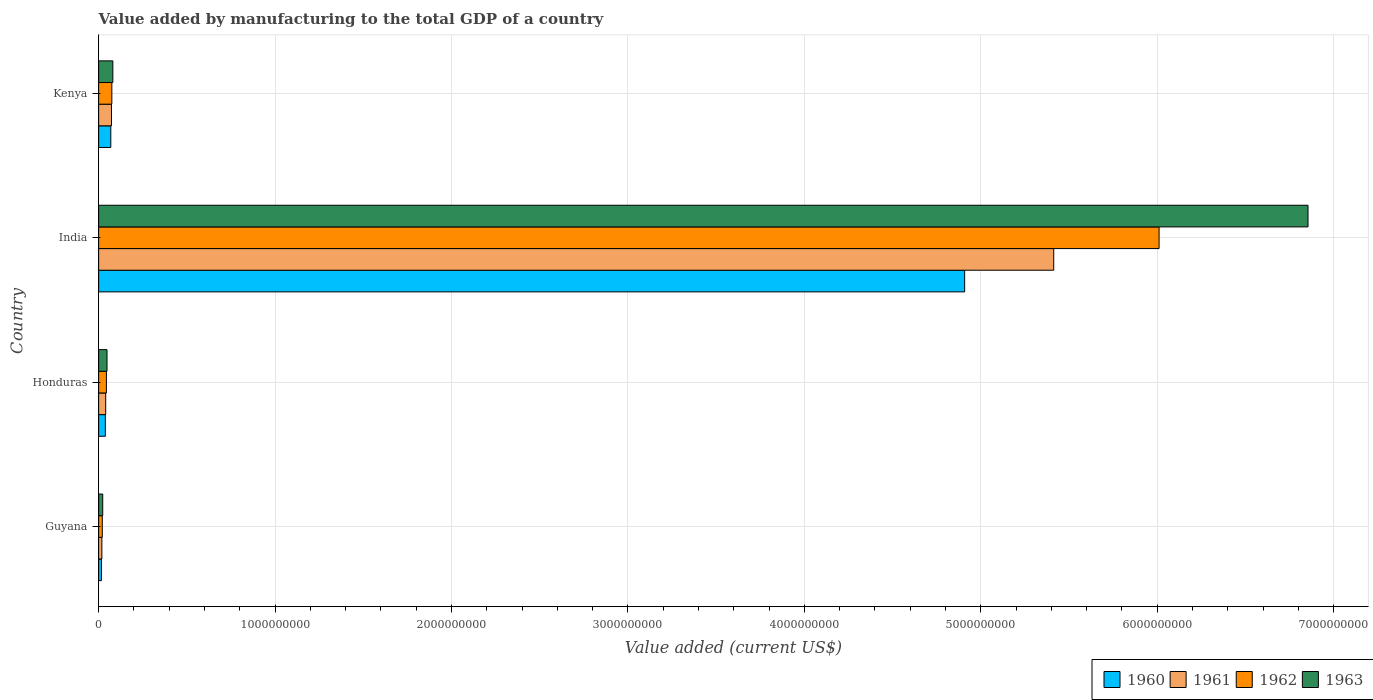How many different coloured bars are there?
Offer a terse response. 4. Are the number of bars per tick equal to the number of legend labels?
Your answer should be compact. Yes. Are the number of bars on each tick of the Y-axis equal?
Keep it short and to the point. Yes. How many bars are there on the 2nd tick from the bottom?
Offer a terse response. 4. What is the label of the 4th group of bars from the top?
Provide a succinct answer. Guyana. What is the value added by manufacturing to the total GDP in 1963 in Honduras?
Make the answer very short. 4.76e+07. Across all countries, what is the maximum value added by manufacturing to the total GDP in 1960?
Provide a succinct answer. 4.91e+09. Across all countries, what is the minimum value added by manufacturing to the total GDP in 1962?
Give a very brief answer. 2.08e+07. In which country was the value added by manufacturing to the total GDP in 1962 maximum?
Offer a terse response. India. In which country was the value added by manufacturing to the total GDP in 1960 minimum?
Provide a short and direct response. Guyana. What is the total value added by manufacturing to the total GDP in 1961 in the graph?
Provide a short and direct response. 5.54e+09. What is the difference between the value added by manufacturing to the total GDP in 1962 in Guyana and that in Kenya?
Your answer should be compact. -5.41e+07. What is the difference between the value added by manufacturing to the total GDP in 1962 in India and the value added by manufacturing to the total GDP in 1963 in Honduras?
Offer a terse response. 5.96e+09. What is the average value added by manufacturing to the total GDP in 1961 per country?
Offer a very short reply. 1.39e+09. What is the difference between the value added by manufacturing to the total GDP in 1962 and value added by manufacturing to the total GDP in 1961 in Guyana?
Make the answer very short. 2.39e+06. In how many countries, is the value added by manufacturing to the total GDP in 1963 greater than 2000000000 US$?
Keep it short and to the point. 1. What is the ratio of the value added by manufacturing to the total GDP in 1961 in Guyana to that in Kenya?
Make the answer very short. 0.25. Is the difference between the value added by manufacturing to the total GDP in 1962 in Guyana and India greater than the difference between the value added by manufacturing to the total GDP in 1961 in Guyana and India?
Your answer should be compact. No. What is the difference between the highest and the second highest value added by manufacturing to the total GDP in 1962?
Provide a short and direct response. 5.94e+09. What is the difference between the highest and the lowest value added by manufacturing to the total GDP in 1962?
Provide a short and direct response. 5.99e+09. Is it the case that in every country, the sum of the value added by manufacturing to the total GDP in 1960 and value added by manufacturing to the total GDP in 1961 is greater than the value added by manufacturing to the total GDP in 1963?
Ensure brevity in your answer.  Yes. How many bars are there?
Provide a short and direct response. 16. How many countries are there in the graph?
Your response must be concise. 4. Does the graph contain any zero values?
Provide a short and direct response. No. What is the title of the graph?
Ensure brevity in your answer.  Value added by manufacturing to the total GDP of a country. Does "1995" appear as one of the legend labels in the graph?
Give a very brief answer. No. What is the label or title of the X-axis?
Make the answer very short. Value added (current US$). What is the Value added (current US$) of 1960 in Guyana?
Offer a very short reply. 1.59e+07. What is the Value added (current US$) of 1961 in Guyana?
Keep it short and to the point. 1.84e+07. What is the Value added (current US$) of 1962 in Guyana?
Offer a very short reply. 2.08e+07. What is the Value added (current US$) in 1963 in Guyana?
Ensure brevity in your answer.  2.32e+07. What is the Value added (current US$) of 1960 in Honduras?
Your answer should be compact. 3.80e+07. What is the Value added (current US$) of 1961 in Honduras?
Provide a succinct answer. 4.00e+07. What is the Value added (current US$) of 1962 in Honduras?
Offer a very short reply. 4.41e+07. What is the Value added (current US$) of 1963 in Honduras?
Your answer should be very brief. 4.76e+07. What is the Value added (current US$) of 1960 in India?
Make the answer very short. 4.91e+09. What is the Value added (current US$) of 1961 in India?
Your answer should be very brief. 5.41e+09. What is the Value added (current US$) in 1962 in India?
Ensure brevity in your answer.  6.01e+09. What is the Value added (current US$) in 1963 in India?
Your response must be concise. 6.85e+09. What is the Value added (current US$) in 1960 in Kenya?
Provide a succinct answer. 6.89e+07. What is the Value added (current US$) in 1961 in Kenya?
Make the answer very short. 7.28e+07. What is the Value added (current US$) in 1962 in Kenya?
Give a very brief answer. 7.48e+07. What is the Value added (current US$) in 1963 in Kenya?
Give a very brief answer. 8.05e+07. Across all countries, what is the maximum Value added (current US$) of 1960?
Your answer should be very brief. 4.91e+09. Across all countries, what is the maximum Value added (current US$) in 1961?
Your response must be concise. 5.41e+09. Across all countries, what is the maximum Value added (current US$) in 1962?
Offer a very short reply. 6.01e+09. Across all countries, what is the maximum Value added (current US$) of 1963?
Give a very brief answer. 6.85e+09. Across all countries, what is the minimum Value added (current US$) of 1960?
Ensure brevity in your answer.  1.59e+07. Across all countries, what is the minimum Value added (current US$) of 1961?
Ensure brevity in your answer.  1.84e+07. Across all countries, what is the minimum Value added (current US$) of 1962?
Your response must be concise. 2.08e+07. Across all countries, what is the minimum Value added (current US$) in 1963?
Offer a terse response. 2.32e+07. What is the total Value added (current US$) of 1960 in the graph?
Offer a very short reply. 5.03e+09. What is the total Value added (current US$) in 1961 in the graph?
Provide a succinct answer. 5.54e+09. What is the total Value added (current US$) in 1962 in the graph?
Keep it short and to the point. 6.15e+09. What is the total Value added (current US$) in 1963 in the graph?
Keep it short and to the point. 7.01e+09. What is the difference between the Value added (current US$) of 1960 in Guyana and that in Honduras?
Your response must be concise. -2.22e+07. What is the difference between the Value added (current US$) of 1961 in Guyana and that in Honduras?
Provide a succinct answer. -2.17e+07. What is the difference between the Value added (current US$) in 1962 in Guyana and that in Honduras?
Your answer should be compact. -2.33e+07. What is the difference between the Value added (current US$) of 1963 in Guyana and that in Honduras?
Offer a terse response. -2.44e+07. What is the difference between the Value added (current US$) in 1960 in Guyana and that in India?
Your answer should be very brief. -4.89e+09. What is the difference between the Value added (current US$) of 1961 in Guyana and that in India?
Offer a very short reply. -5.40e+09. What is the difference between the Value added (current US$) of 1962 in Guyana and that in India?
Give a very brief answer. -5.99e+09. What is the difference between the Value added (current US$) of 1963 in Guyana and that in India?
Keep it short and to the point. -6.83e+09. What is the difference between the Value added (current US$) of 1960 in Guyana and that in Kenya?
Provide a succinct answer. -5.30e+07. What is the difference between the Value added (current US$) in 1961 in Guyana and that in Kenya?
Offer a terse response. -5.45e+07. What is the difference between the Value added (current US$) of 1962 in Guyana and that in Kenya?
Make the answer very short. -5.41e+07. What is the difference between the Value added (current US$) of 1963 in Guyana and that in Kenya?
Offer a very short reply. -5.74e+07. What is the difference between the Value added (current US$) of 1960 in Honduras and that in India?
Offer a very short reply. -4.87e+09. What is the difference between the Value added (current US$) in 1961 in Honduras and that in India?
Your response must be concise. -5.37e+09. What is the difference between the Value added (current US$) of 1962 in Honduras and that in India?
Your answer should be very brief. -5.97e+09. What is the difference between the Value added (current US$) of 1963 in Honduras and that in India?
Make the answer very short. -6.81e+09. What is the difference between the Value added (current US$) of 1960 in Honduras and that in Kenya?
Offer a terse response. -3.09e+07. What is the difference between the Value added (current US$) of 1961 in Honduras and that in Kenya?
Provide a short and direct response. -3.28e+07. What is the difference between the Value added (current US$) in 1962 in Honduras and that in Kenya?
Your answer should be very brief. -3.07e+07. What is the difference between the Value added (current US$) in 1963 in Honduras and that in Kenya?
Your answer should be compact. -3.30e+07. What is the difference between the Value added (current US$) of 1960 in India and that in Kenya?
Keep it short and to the point. 4.84e+09. What is the difference between the Value added (current US$) in 1961 in India and that in Kenya?
Give a very brief answer. 5.34e+09. What is the difference between the Value added (current US$) in 1962 in India and that in Kenya?
Provide a short and direct response. 5.94e+09. What is the difference between the Value added (current US$) of 1963 in India and that in Kenya?
Make the answer very short. 6.77e+09. What is the difference between the Value added (current US$) of 1960 in Guyana and the Value added (current US$) of 1961 in Honduras?
Your response must be concise. -2.42e+07. What is the difference between the Value added (current US$) in 1960 in Guyana and the Value added (current US$) in 1962 in Honduras?
Provide a succinct answer. -2.82e+07. What is the difference between the Value added (current US$) of 1960 in Guyana and the Value added (current US$) of 1963 in Honduras?
Your response must be concise. -3.17e+07. What is the difference between the Value added (current US$) of 1961 in Guyana and the Value added (current US$) of 1962 in Honduras?
Give a very brief answer. -2.57e+07. What is the difference between the Value added (current US$) of 1961 in Guyana and the Value added (current US$) of 1963 in Honduras?
Make the answer very short. -2.92e+07. What is the difference between the Value added (current US$) of 1962 in Guyana and the Value added (current US$) of 1963 in Honduras?
Ensure brevity in your answer.  -2.68e+07. What is the difference between the Value added (current US$) in 1960 in Guyana and the Value added (current US$) in 1961 in India?
Offer a terse response. -5.40e+09. What is the difference between the Value added (current US$) in 1960 in Guyana and the Value added (current US$) in 1962 in India?
Make the answer very short. -5.99e+09. What is the difference between the Value added (current US$) in 1960 in Guyana and the Value added (current US$) in 1963 in India?
Offer a terse response. -6.84e+09. What is the difference between the Value added (current US$) in 1961 in Guyana and the Value added (current US$) in 1962 in India?
Make the answer very short. -5.99e+09. What is the difference between the Value added (current US$) in 1961 in Guyana and the Value added (current US$) in 1963 in India?
Your answer should be very brief. -6.84e+09. What is the difference between the Value added (current US$) of 1962 in Guyana and the Value added (current US$) of 1963 in India?
Your answer should be very brief. -6.83e+09. What is the difference between the Value added (current US$) of 1960 in Guyana and the Value added (current US$) of 1961 in Kenya?
Provide a succinct answer. -5.70e+07. What is the difference between the Value added (current US$) of 1960 in Guyana and the Value added (current US$) of 1962 in Kenya?
Your response must be concise. -5.90e+07. What is the difference between the Value added (current US$) in 1960 in Guyana and the Value added (current US$) in 1963 in Kenya?
Provide a short and direct response. -6.47e+07. What is the difference between the Value added (current US$) of 1961 in Guyana and the Value added (current US$) of 1962 in Kenya?
Your response must be concise. -5.65e+07. What is the difference between the Value added (current US$) of 1961 in Guyana and the Value added (current US$) of 1963 in Kenya?
Make the answer very short. -6.22e+07. What is the difference between the Value added (current US$) of 1962 in Guyana and the Value added (current US$) of 1963 in Kenya?
Your response must be concise. -5.98e+07. What is the difference between the Value added (current US$) of 1960 in Honduras and the Value added (current US$) of 1961 in India?
Make the answer very short. -5.38e+09. What is the difference between the Value added (current US$) in 1960 in Honduras and the Value added (current US$) in 1962 in India?
Make the answer very short. -5.97e+09. What is the difference between the Value added (current US$) of 1960 in Honduras and the Value added (current US$) of 1963 in India?
Keep it short and to the point. -6.82e+09. What is the difference between the Value added (current US$) of 1961 in Honduras and the Value added (current US$) of 1962 in India?
Offer a terse response. -5.97e+09. What is the difference between the Value added (current US$) in 1961 in Honduras and the Value added (current US$) in 1963 in India?
Offer a very short reply. -6.81e+09. What is the difference between the Value added (current US$) of 1962 in Honduras and the Value added (current US$) of 1963 in India?
Your answer should be compact. -6.81e+09. What is the difference between the Value added (current US$) in 1960 in Honduras and the Value added (current US$) in 1961 in Kenya?
Provide a succinct answer. -3.48e+07. What is the difference between the Value added (current US$) in 1960 in Honduras and the Value added (current US$) in 1962 in Kenya?
Ensure brevity in your answer.  -3.68e+07. What is the difference between the Value added (current US$) of 1960 in Honduras and the Value added (current US$) of 1963 in Kenya?
Make the answer very short. -4.25e+07. What is the difference between the Value added (current US$) of 1961 in Honduras and the Value added (current US$) of 1962 in Kenya?
Ensure brevity in your answer.  -3.48e+07. What is the difference between the Value added (current US$) of 1961 in Honduras and the Value added (current US$) of 1963 in Kenya?
Your answer should be very brief. -4.05e+07. What is the difference between the Value added (current US$) of 1962 in Honduras and the Value added (current US$) of 1963 in Kenya?
Provide a short and direct response. -3.64e+07. What is the difference between the Value added (current US$) of 1960 in India and the Value added (current US$) of 1961 in Kenya?
Provide a succinct answer. 4.84e+09. What is the difference between the Value added (current US$) in 1960 in India and the Value added (current US$) in 1962 in Kenya?
Your answer should be compact. 4.83e+09. What is the difference between the Value added (current US$) in 1960 in India and the Value added (current US$) in 1963 in Kenya?
Give a very brief answer. 4.83e+09. What is the difference between the Value added (current US$) of 1961 in India and the Value added (current US$) of 1962 in Kenya?
Offer a terse response. 5.34e+09. What is the difference between the Value added (current US$) of 1961 in India and the Value added (current US$) of 1963 in Kenya?
Provide a succinct answer. 5.33e+09. What is the difference between the Value added (current US$) in 1962 in India and the Value added (current US$) in 1963 in Kenya?
Offer a terse response. 5.93e+09. What is the average Value added (current US$) of 1960 per country?
Ensure brevity in your answer.  1.26e+09. What is the average Value added (current US$) of 1961 per country?
Offer a very short reply. 1.39e+09. What is the average Value added (current US$) in 1962 per country?
Provide a short and direct response. 1.54e+09. What is the average Value added (current US$) of 1963 per country?
Your answer should be compact. 1.75e+09. What is the difference between the Value added (current US$) of 1960 and Value added (current US$) of 1961 in Guyana?
Provide a short and direct response. -2.51e+06. What is the difference between the Value added (current US$) of 1960 and Value added (current US$) of 1962 in Guyana?
Your answer should be compact. -4.90e+06. What is the difference between the Value added (current US$) of 1960 and Value added (current US$) of 1963 in Guyana?
Ensure brevity in your answer.  -7.29e+06. What is the difference between the Value added (current US$) in 1961 and Value added (current US$) in 1962 in Guyana?
Give a very brief answer. -2.39e+06. What is the difference between the Value added (current US$) of 1961 and Value added (current US$) of 1963 in Guyana?
Your response must be concise. -4.78e+06. What is the difference between the Value added (current US$) of 1962 and Value added (current US$) of 1963 in Guyana?
Give a very brief answer. -2.39e+06. What is the difference between the Value added (current US$) in 1960 and Value added (current US$) in 1962 in Honduras?
Give a very brief answer. -6.05e+06. What is the difference between the Value added (current US$) in 1960 and Value added (current US$) in 1963 in Honduras?
Your response must be concise. -9.50e+06. What is the difference between the Value added (current US$) of 1961 and Value added (current US$) of 1962 in Honduras?
Offer a very short reply. -4.05e+06. What is the difference between the Value added (current US$) in 1961 and Value added (current US$) in 1963 in Honduras?
Offer a very short reply. -7.50e+06. What is the difference between the Value added (current US$) of 1962 and Value added (current US$) of 1963 in Honduras?
Make the answer very short. -3.45e+06. What is the difference between the Value added (current US$) in 1960 and Value added (current US$) in 1961 in India?
Provide a succinct answer. -5.05e+08. What is the difference between the Value added (current US$) of 1960 and Value added (current US$) of 1962 in India?
Make the answer very short. -1.10e+09. What is the difference between the Value added (current US$) of 1960 and Value added (current US$) of 1963 in India?
Your answer should be compact. -1.95e+09. What is the difference between the Value added (current US$) in 1961 and Value added (current US$) in 1962 in India?
Your answer should be very brief. -5.97e+08. What is the difference between the Value added (current US$) in 1961 and Value added (current US$) in 1963 in India?
Your answer should be compact. -1.44e+09. What is the difference between the Value added (current US$) of 1962 and Value added (current US$) of 1963 in India?
Keep it short and to the point. -8.44e+08. What is the difference between the Value added (current US$) in 1960 and Value added (current US$) in 1961 in Kenya?
Your response must be concise. -3.93e+06. What is the difference between the Value added (current US$) in 1960 and Value added (current US$) in 1962 in Kenya?
Give a very brief answer. -5.94e+06. What is the difference between the Value added (current US$) of 1960 and Value added (current US$) of 1963 in Kenya?
Provide a succinct answer. -1.16e+07. What is the difference between the Value added (current US$) in 1961 and Value added (current US$) in 1962 in Kenya?
Provide a succinct answer. -2.00e+06. What is the difference between the Value added (current US$) of 1961 and Value added (current US$) of 1963 in Kenya?
Give a very brief answer. -7.70e+06. What is the difference between the Value added (current US$) of 1962 and Value added (current US$) of 1963 in Kenya?
Offer a very short reply. -5.70e+06. What is the ratio of the Value added (current US$) in 1960 in Guyana to that in Honduras?
Keep it short and to the point. 0.42. What is the ratio of the Value added (current US$) of 1961 in Guyana to that in Honduras?
Offer a terse response. 0.46. What is the ratio of the Value added (current US$) in 1962 in Guyana to that in Honduras?
Your answer should be very brief. 0.47. What is the ratio of the Value added (current US$) in 1963 in Guyana to that in Honduras?
Your answer should be very brief. 0.49. What is the ratio of the Value added (current US$) in 1960 in Guyana to that in India?
Offer a very short reply. 0. What is the ratio of the Value added (current US$) of 1961 in Guyana to that in India?
Your answer should be very brief. 0. What is the ratio of the Value added (current US$) of 1962 in Guyana to that in India?
Provide a succinct answer. 0. What is the ratio of the Value added (current US$) in 1963 in Guyana to that in India?
Offer a terse response. 0. What is the ratio of the Value added (current US$) in 1960 in Guyana to that in Kenya?
Your answer should be compact. 0.23. What is the ratio of the Value added (current US$) in 1961 in Guyana to that in Kenya?
Offer a terse response. 0.25. What is the ratio of the Value added (current US$) in 1962 in Guyana to that in Kenya?
Make the answer very short. 0.28. What is the ratio of the Value added (current US$) of 1963 in Guyana to that in Kenya?
Ensure brevity in your answer.  0.29. What is the ratio of the Value added (current US$) of 1960 in Honduras to that in India?
Provide a short and direct response. 0.01. What is the ratio of the Value added (current US$) in 1961 in Honduras to that in India?
Ensure brevity in your answer.  0.01. What is the ratio of the Value added (current US$) in 1962 in Honduras to that in India?
Provide a succinct answer. 0.01. What is the ratio of the Value added (current US$) in 1963 in Honduras to that in India?
Offer a very short reply. 0.01. What is the ratio of the Value added (current US$) of 1960 in Honduras to that in Kenya?
Your answer should be compact. 0.55. What is the ratio of the Value added (current US$) in 1961 in Honduras to that in Kenya?
Your response must be concise. 0.55. What is the ratio of the Value added (current US$) in 1962 in Honduras to that in Kenya?
Offer a very short reply. 0.59. What is the ratio of the Value added (current US$) in 1963 in Honduras to that in Kenya?
Give a very brief answer. 0.59. What is the ratio of the Value added (current US$) of 1960 in India to that in Kenya?
Offer a terse response. 71.24. What is the ratio of the Value added (current US$) in 1961 in India to that in Kenya?
Provide a succinct answer. 74.32. What is the ratio of the Value added (current US$) in 1962 in India to that in Kenya?
Offer a very short reply. 80.31. What is the ratio of the Value added (current US$) in 1963 in India to that in Kenya?
Provide a short and direct response. 85.11. What is the difference between the highest and the second highest Value added (current US$) in 1960?
Your answer should be very brief. 4.84e+09. What is the difference between the highest and the second highest Value added (current US$) of 1961?
Ensure brevity in your answer.  5.34e+09. What is the difference between the highest and the second highest Value added (current US$) in 1962?
Your response must be concise. 5.94e+09. What is the difference between the highest and the second highest Value added (current US$) of 1963?
Your answer should be compact. 6.77e+09. What is the difference between the highest and the lowest Value added (current US$) in 1960?
Make the answer very short. 4.89e+09. What is the difference between the highest and the lowest Value added (current US$) in 1961?
Provide a succinct answer. 5.40e+09. What is the difference between the highest and the lowest Value added (current US$) of 1962?
Offer a terse response. 5.99e+09. What is the difference between the highest and the lowest Value added (current US$) in 1963?
Give a very brief answer. 6.83e+09. 